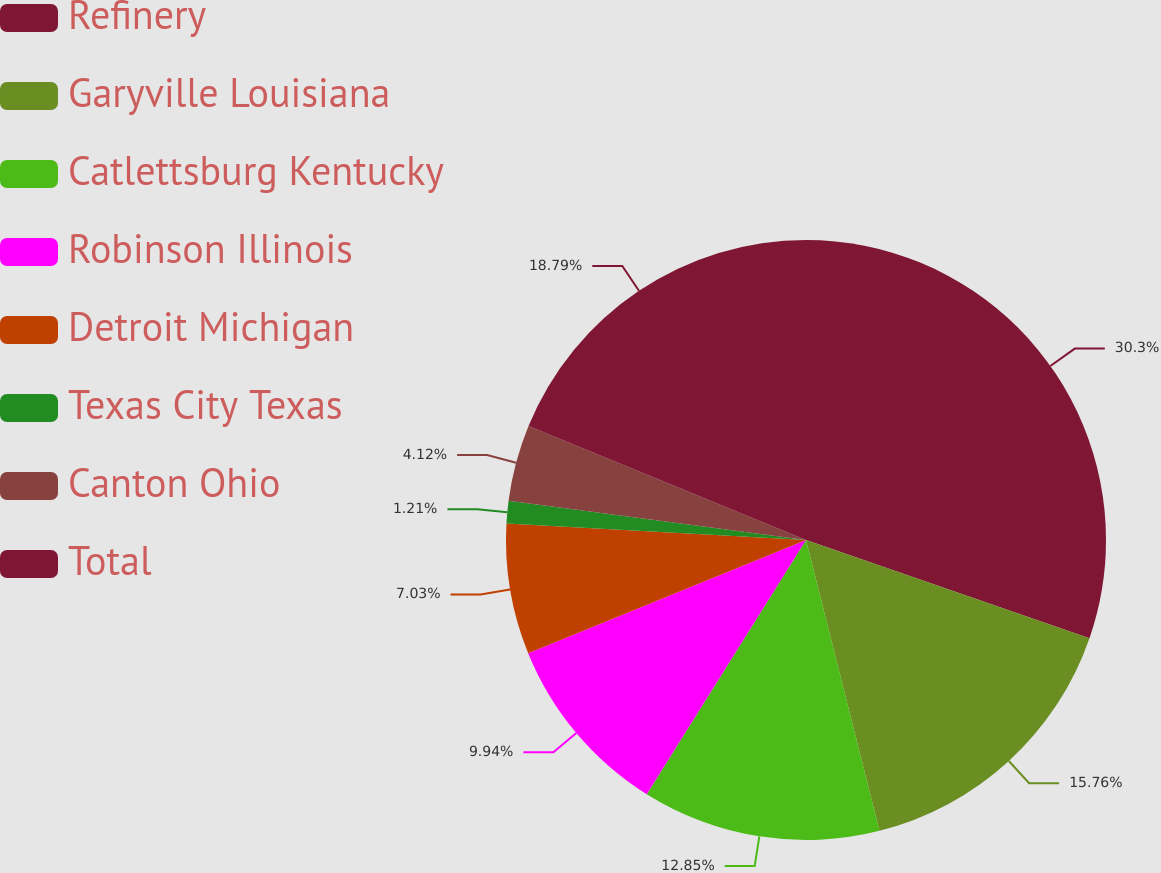Convert chart. <chart><loc_0><loc_0><loc_500><loc_500><pie_chart><fcel>Refinery<fcel>Garyville Louisiana<fcel>Catlettsburg Kentucky<fcel>Robinson Illinois<fcel>Detroit Michigan<fcel>Texas City Texas<fcel>Canton Ohio<fcel>Total<nl><fcel>30.31%<fcel>15.76%<fcel>12.85%<fcel>9.94%<fcel>7.03%<fcel>1.21%<fcel>4.12%<fcel>18.8%<nl></chart> 